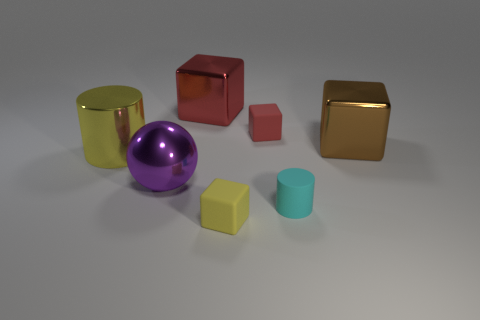There is a tiny rubber cube that is in front of the brown cube; what color is it?
Keep it short and to the point. Yellow. There is a shiny cube that is on the left side of the brown block; is there a shiny sphere to the right of it?
Your answer should be compact. No. How many other objects are the same color as the sphere?
Give a very brief answer. 0. Do the metallic cube to the left of the red matte object and the yellow thing left of the big red object have the same size?
Your answer should be compact. Yes. What is the size of the shiny cube in front of the tiny rubber block that is behind the cyan rubber cylinder?
Your answer should be compact. Large. There is a object that is both on the left side of the large red cube and to the right of the metal cylinder; what material is it?
Offer a very short reply. Metal. The big sphere is what color?
Your answer should be very brief. Purple. Is there any other thing that has the same material as the purple ball?
Offer a very short reply. Yes. There is a metallic thing that is on the right side of the red shiny object; what shape is it?
Your response must be concise. Cube. Are there any tiny red cubes on the right side of the red cube in front of the red thing that is left of the yellow cube?
Offer a terse response. No. 